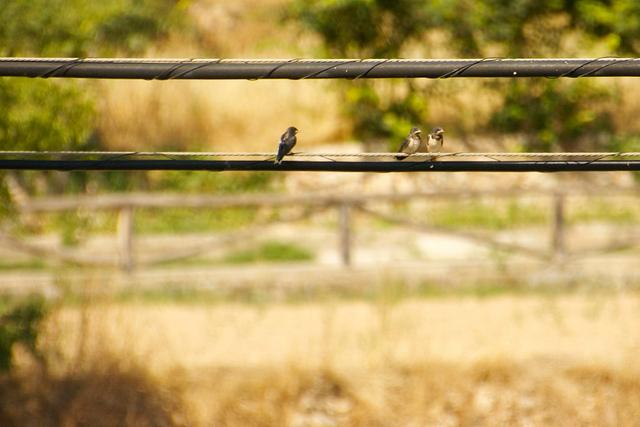What kind of fence is in the background?
Short answer required. Wood. Where are the birds?
Answer briefly. On wire. Is this a Highland cow?
Concise answer only. No. How many birds are there?
Quick response, please. 3. 